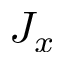Convert formula to latex. <formula><loc_0><loc_0><loc_500><loc_500>J _ { x }</formula> 